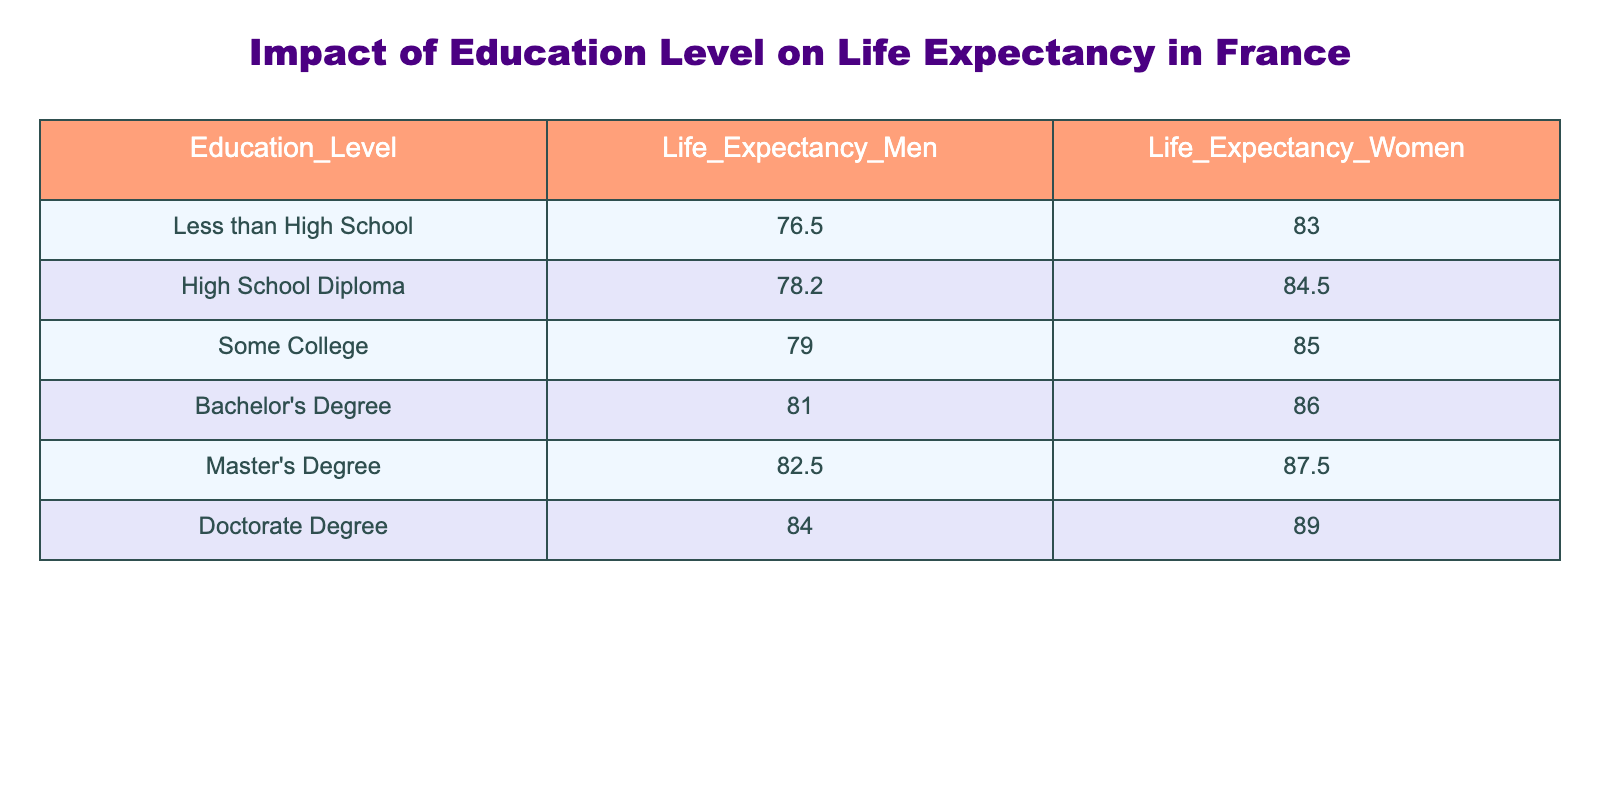What is the life expectancy for men with a Master's Degree? The table indicates that for men holding a Master's Degree, the life expectancy is 82.5 years according to the provided data.
Answer: 82.5 What is the life expectancy for women who have less than a high school education? According to the table, women with less than a high school education have a life expectancy of 83.0 years.
Answer: 83.0 Is it true that men with a Doctorate Degree have a higher life expectancy than women with a Bachelor's Degree? Looking at the table, men with a Doctorate Degree have a life expectancy of 84.0 years, while women with a Bachelor's Degree have a life expectancy of 86.0 years. Thus, it's false that men with a Doctorate have a higher life expectancy, as women with a Bachelor's Degree live longer.
Answer: No What is the difference in life expectancy between men with a Bachelor's Degree and those with less than a high school education? For men with a Bachelor's Degree, the life expectancy is 81.0 years, and for those with less than a high school education, it is 76.5 years. The difference can be calculated by subtracting these two figures: 81.0 - 76.5 = 4.5 years.
Answer: 4.5 What is the average life expectancy for women with a High School Diploma and some College education? The table lists women with a High School Diploma at 84.5 years and those with some College education at 85.0 years. To find the average, we sum these two values (84.5 + 85.0 = 169.5) and divide by the number of values (2): 169.5 / 2 = 84.75 years.
Answer: 84.75 Which education level has the highest life expectancy for men? Referring to the table, men with a Doctorate Degree have the highest life expectancy at 84.0 years, making this the most advantageous education level in terms of longevity.
Answer: Doctorate Degree How much longer do women with a Doctorate Degree live compared to those with less than a high school education? The life expectancy for women with a Doctorate Degree is 89.0 years, while those with less than a high school education live up to 83.0 years. The difference is 89.0 - 83.0 = 6.0 years, indicating that women with a Doctorate Degree live 6 years longer.
Answer: 6.0 